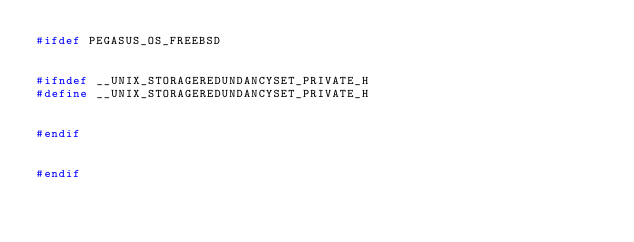Convert code to text. <code><loc_0><loc_0><loc_500><loc_500><_C++_>#ifdef PEGASUS_OS_FREEBSD


#ifndef __UNIX_STORAGEREDUNDANCYSET_PRIVATE_H
#define __UNIX_STORAGEREDUNDANCYSET_PRIVATE_H


#endif


#endif
</code> 